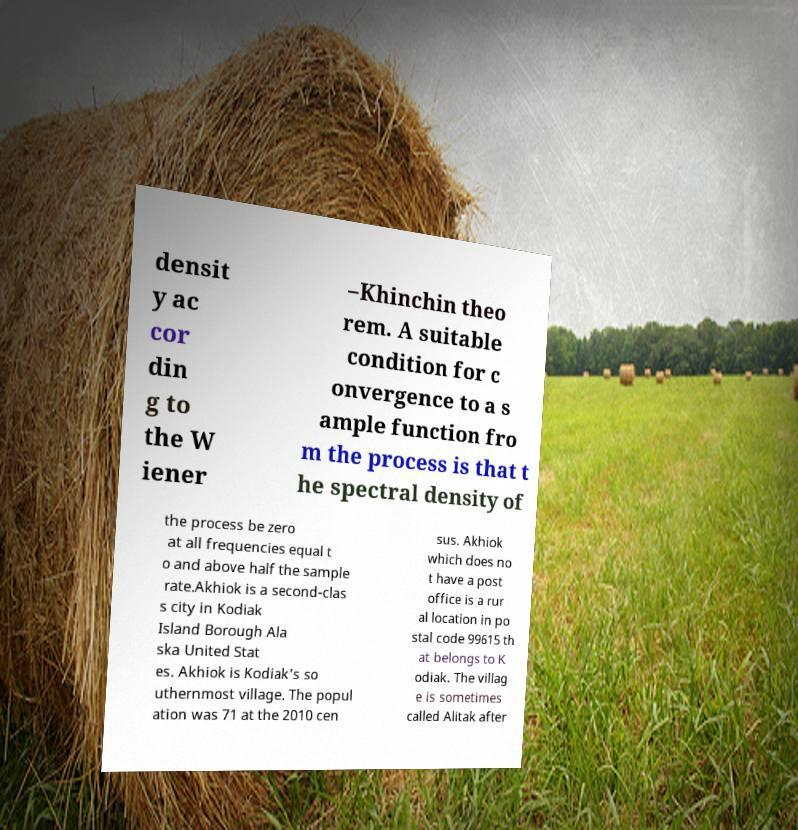Can you accurately transcribe the text from the provided image for me? densit y ac cor din g to the W iener –Khinchin theo rem. A suitable condition for c onvergence to a s ample function fro m the process is that t he spectral density of the process be zero at all frequencies equal t o and above half the sample rate.Akhiok is a second-clas s city in Kodiak Island Borough Ala ska United Stat es. Akhiok is Kodiak's so uthernmost village. The popul ation was 71 at the 2010 cen sus. Akhiok which does no t have a post office is a rur al location in po stal code 99615 th at belongs to K odiak. The villag e is sometimes called Alitak after 